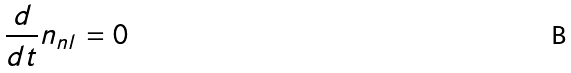Convert formula to latex. <formula><loc_0><loc_0><loc_500><loc_500>\frac { d } { d t } { n _ { n l } } = 0</formula> 